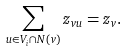Convert formula to latex. <formula><loc_0><loc_0><loc_500><loc_500>\sum _ { u \in V _ { i } \cap N ( v ) } z _ { v u } = z _ { v } .</formula> 